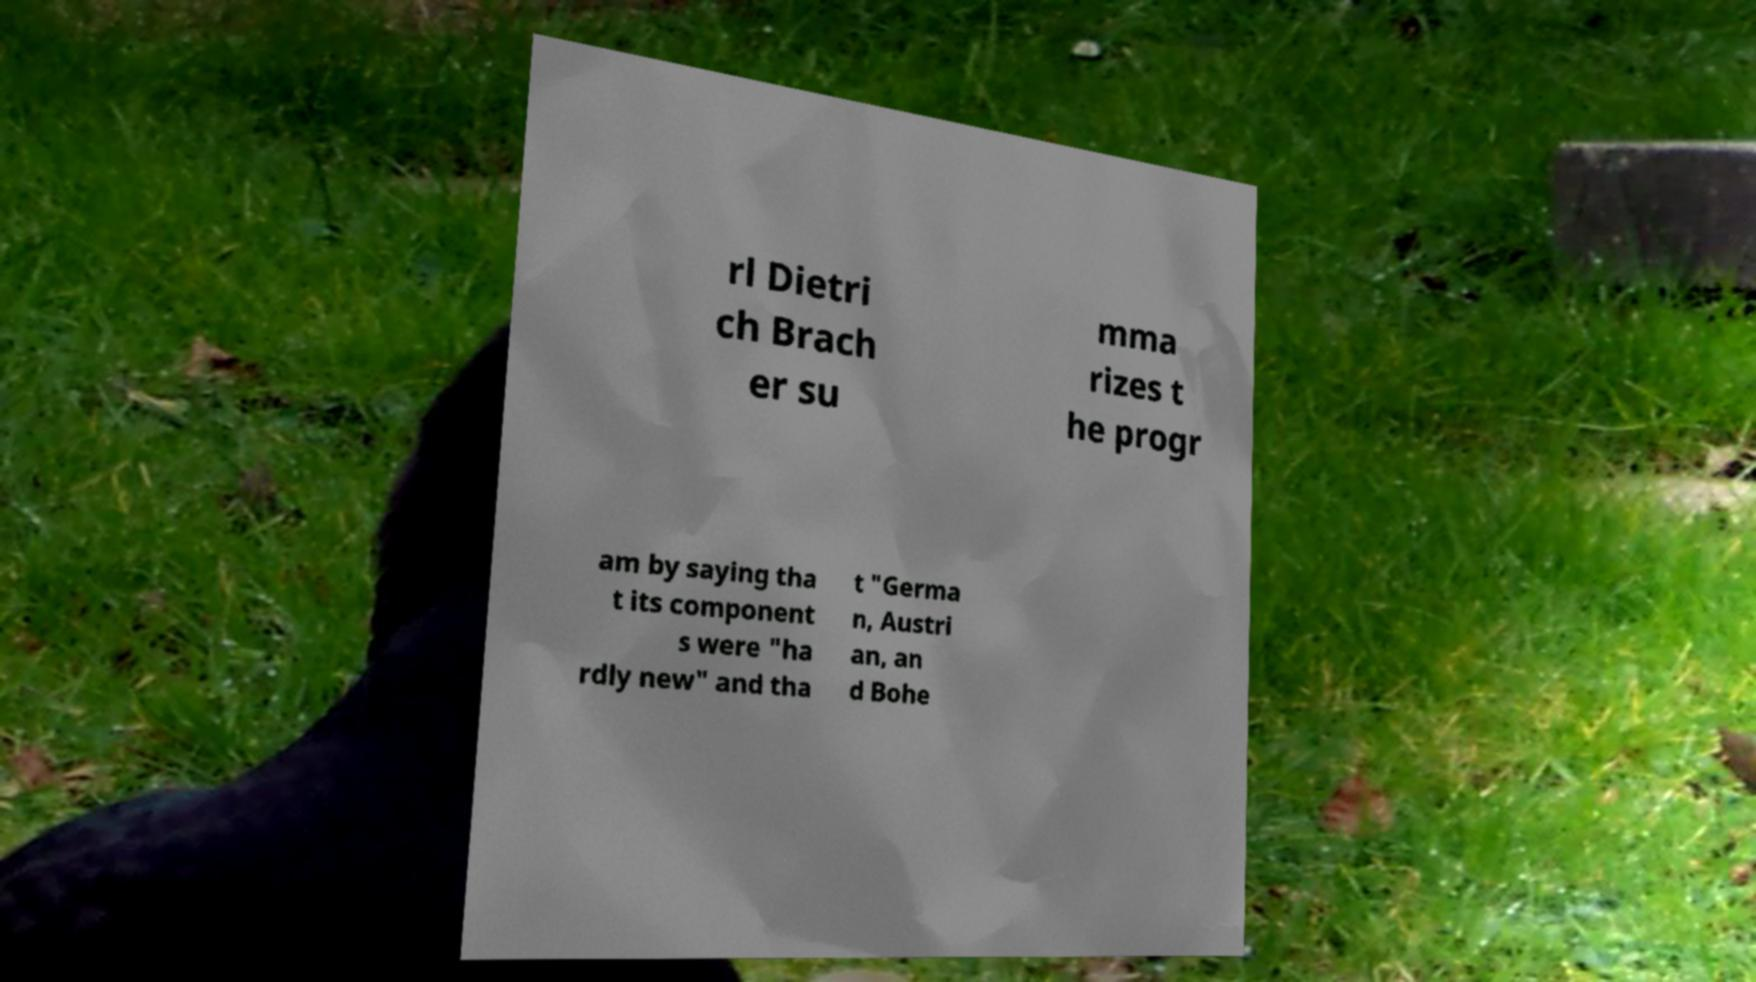Please read and relay the text visible in this image. What does it say? rl Dietri ch Brach er su mma rizes t he progr am by saying tha t its component s were "ha rdly new" and tha t "Germa n, Austri an, an d Bohe 